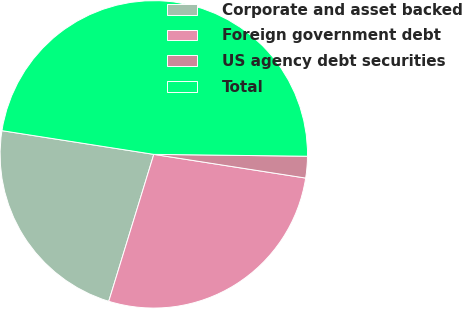Convert chart. <chart><loc_0><loc_0><loc_500><loc_500><pie_chart><fcel>Corporate and asset backed<fcel>Foreign government debt<fcel>US agency debt securities<fcel>Total<nl><fcel>22.73%<fcel>27.27%<fcel>2.27%<fcel>47.73%<nl></chart> 